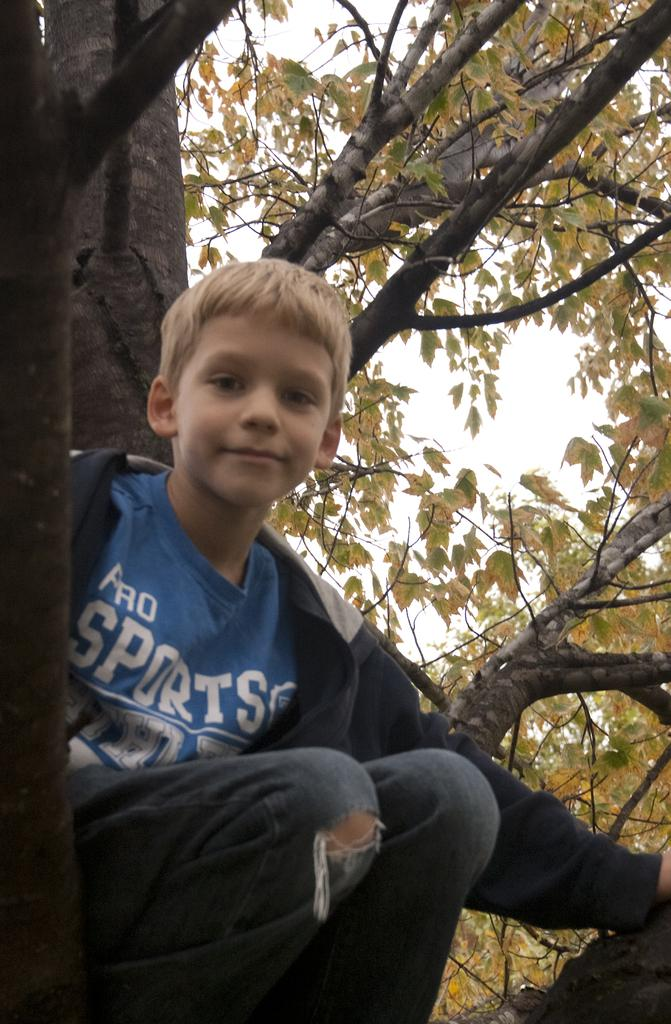What is the main subject of the image? There is a child in the image. Where is the child located in the image? The child is sitting on a branch of a tree. What can be seen around the child in the image? There are leaves visible in the image. What is visible in the background of the image? The sky is visible in the image. What game is the child playing in the image? There is no indication of a game being played in the image. 